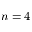<formula> <loc_0><loc_0><loc_500><loc_500>n = 4</formula> 